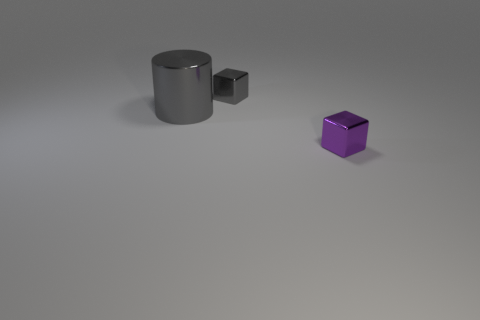There is a thing that is both behind the small purple block and right of the big gray metallic object; what shape is it?
Your answer should be compact. Cube. What is the shape of the large thing that is the same material as the purple cube?
Your response must be concise. Cylinder. There is a small gray thing that is to the right of the large gray metal object; what is its material?
Provide a succinct answer. Metal. There is a block that is right of the gray block; is its size the same as the cube behind the large gray object?
Offer a very short reply. Yes. What is the color of the cylinder?
Your answer should be compact. Gray. Does the small object that is to the left of the purple block have the same shape as the big shiny object?
Offer a very short reply. No. What shape is the purple object that is the same size as the gray block?
Offer a very short reply. Cube. Is there a tiny object of the same color as the large thing?
Provide a short and direct response. Yes. Is the color of the large object the same as the metal thing behind the gray cylinder?
Keep it short and to the point. Yes. The object that is to the left of the tiny gray shiny thing that is behind the large gray shiny thing is what color?
Your answer should be compact. Gray. 